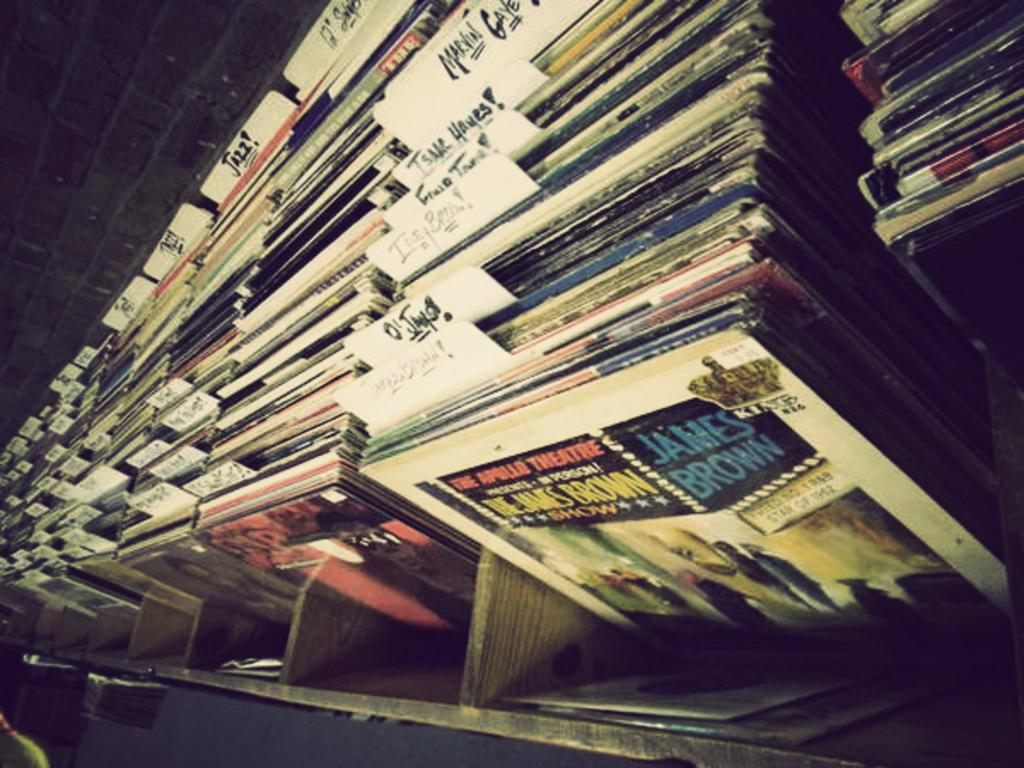<image>
Offer a succinct explanation of the picture presented. a James Brown album among many other ones 